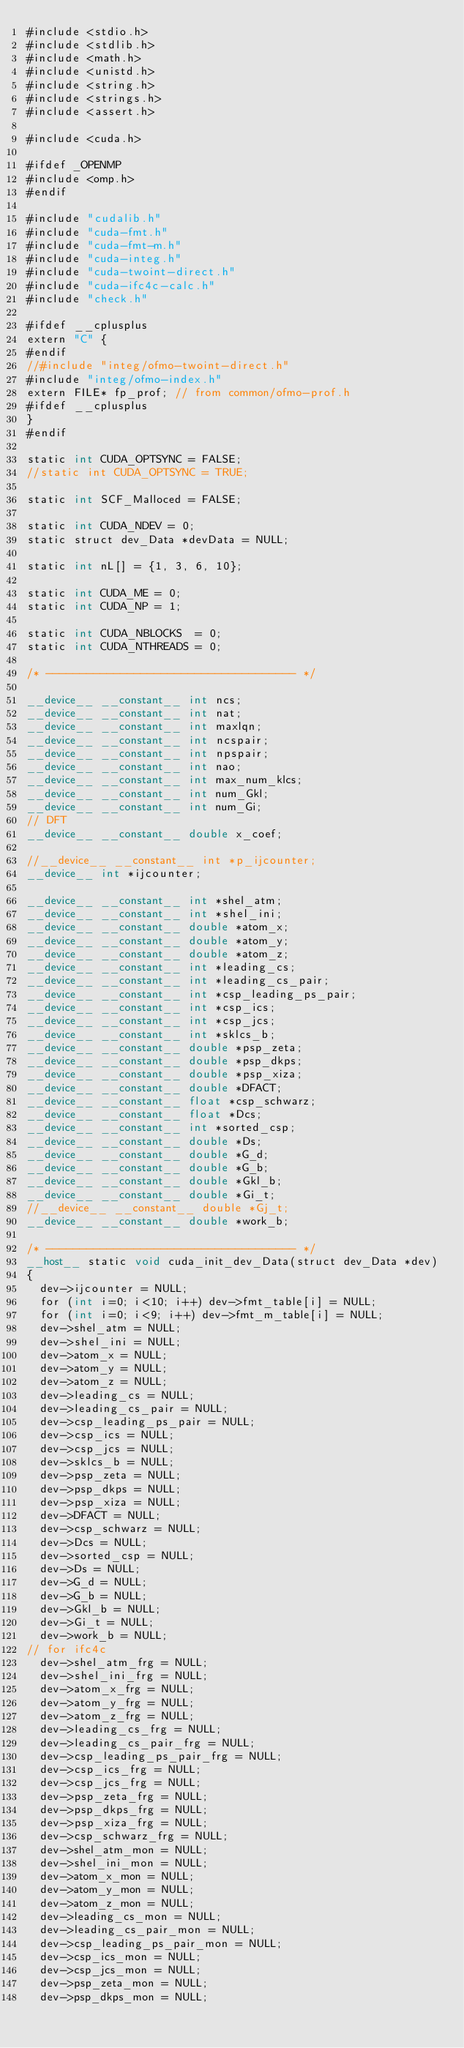<code> <loc_0><loc_0><loc_500><loc_500><_Cuda_>#include <stdio.h>
#include <stdlib.h>
#include <math.h>
#include <unistd.h>
#include <string.h>
#include <strings.h>
#include <assert.h>

#include <cuda.h>

#ifdef _OPENMP
#include <omp.h>
#endif

#include "cudalib.h"
#include "cuda-fmt.h"
#include "cuda-fmt-m.h"
#include "cuda-integ.h"
#include "cuda-twoint-direct.h"
#include "cuda-ifc4c-calc.h"
#include "check.h"

#ifdef __cplusplus
extern "C" {
#endif
//#include "integ/ofmo-twoint-direct.h"
#include "integ/ofmo-index.h"
extern FILE* fp_prof; // from common/ofmo-prof.h
#ifdef __cplusplus
}
#endif

static int CUDA_OPTSYNC = FALSE;
//static int CUDA_OPTSYNC = TRUE;

static int SCF_Malloced = FALSE;

static int CUDA_NDEV = 0;
static struct dev_Data *devData = NULL;

static int nL[] = {1, 3, 6, 10};

static int CUDA_ME = 0;
static int CUDA_NP = 1;

static int CUDA_NBLOCKS  = 0;
static int CUDA_NTHREADS = 0;

/* ------------------------------------- */

__device__ __constant__ int ncs;
__device__ __constant__ int nat;
__device__ __constant__ int maxlqn;
__device__ __constant__ int ncspair;
__device__ __constant__ int npspair;
__device__ __constant__ int nao;
__device__ __constant__ int max_num_klcs;
__device__ __constant__ int num_Gkl;
__device__ __constant__ int num_Gi;
// DFT
__device__ __constant__ double x_coef;

//__device__ __constant__ int *p_ijcounter;
__device__ int *ijcounter;

__device__ __constant__ int *shel_atm;
__device__ __constant__ int *shel_ini;
__device__ __constant__ double *atom_x;
__device__ __constant__ double *atom_y;
__device__ __constant__ double *atom_z;
__device__ __constant__ int *leading_cs;
__device__ __constant__ int *leading_cs_pair;
__device__ __constant__ int *csp_leading_ps_pair;
__device__ __constant__ int *csp_ics;
__device__ __constant__ int *csp_jcs;
__device__ __constant__ int *sklcs_b;
__device__ __constant__ double *psp_zeta;
__device__ __constant__ double *psp_dkps;
__device__ __constant__ double *psp_xiza;
__device__ __constant__ double *DFACT;
__device__ __constant__ float *csp_schwarz;
__device__ __constant__ float *Dcs;
__device__ __constant__ int *sorted_csp;
__device__ __constant__ double *Ds;
__device__ __constant__ double *G_d;
__device__ __constant__ double *G_b;
__device__ __constant__ double *Gkl_b;
__device__ __constant__ double *Gi_t;
//__device__ __constant__ double *Gj_t;
__device__ __constant__ double *work_b;

/* ------------------------------------- */
__host__ static void cuda_init_dev_Data(struct dev_Data *dev)
{
  dev->ijcounter = NULL;
  for (int i=0; i<10; i++) dev->fmt_table[i] = NULL;
  for (int i=0; i<9; i++) dev->fmt_m_table[i] = NULL;
  dev->shel_atm = NULL;
  dev->shel_ini = NULL;
  dev->atom_x = NULL;
  dev->atom_y = NULL;
  dev->atom_z = NULL;
  dev->leading_cs = NULL;
  dev->leading_cs_pair = NULL;
  dev->csp_leading_ps_pair = NULL;
  dev->csp_ics = NULL;
  dev->csp_jcs = NULL;
  dev->sklcs_b = NULL;
  dev->psp_zeta = NULL;
  dev->psp_dkps = NULL;
  dev->psp_xiza = NULL;
  dev->DFACT = NULL;
  dev->csp_schwarz = NULL;
  dev->Dcs = NULL;
  dev->sorted_csp = NULL;
  dev->Ds = NULL;
  dev->G_d = NULL;
  dev->G_b = NULL;
  dev->Gkl_b = NULL;
  dev->Gi_t = NULL;
  dev->work_b = NULL;
// for ifc4c
  dev->shel_atm_frg = NULL;
  dev->shel_ini_frg = NULL;
  dev->atom_x_frg = NULL;
  dev->atom_y_frg = NULL;
  dev->atom_z_frg = NULL;
  dev->leading_cs_frg = NULL;
  dev->leading_cs_pair_frg = NULL;
  dev->csp_leading_ps_pair_frg = NULL;
  dev->csp_ics_frg = NULL;
  dev->csp_jcs_frg = NULL;
  dev->psp_zeta_frg = NULL;
  dev->psp_dkps_frg = NULL;
  dev->psp_xiza_frg = NULL;
  dev->csp_schwarz_frg = NULL;
  dev->shel_atm_mon = NULL;
  dev->shel_ini_mon = NULL;
  dev->atom_x_mon = NULL;
  dev->atom_y_mon = NULL;
  dev->atom_z_mon = NULL;
  dev->leading_cs_mon = NULL;
  dev->leading_cs_pair_mon = NULL;
  dev->csp_leading_ps_pair_mon = NULL;
  dev->csp_ics_mon = NULL;
  dev->csp_jcs_mon = NULL;
  dev->psp_zeta_mon = NULL;
  dev->psp_dkps_mon = NULL;</code> 